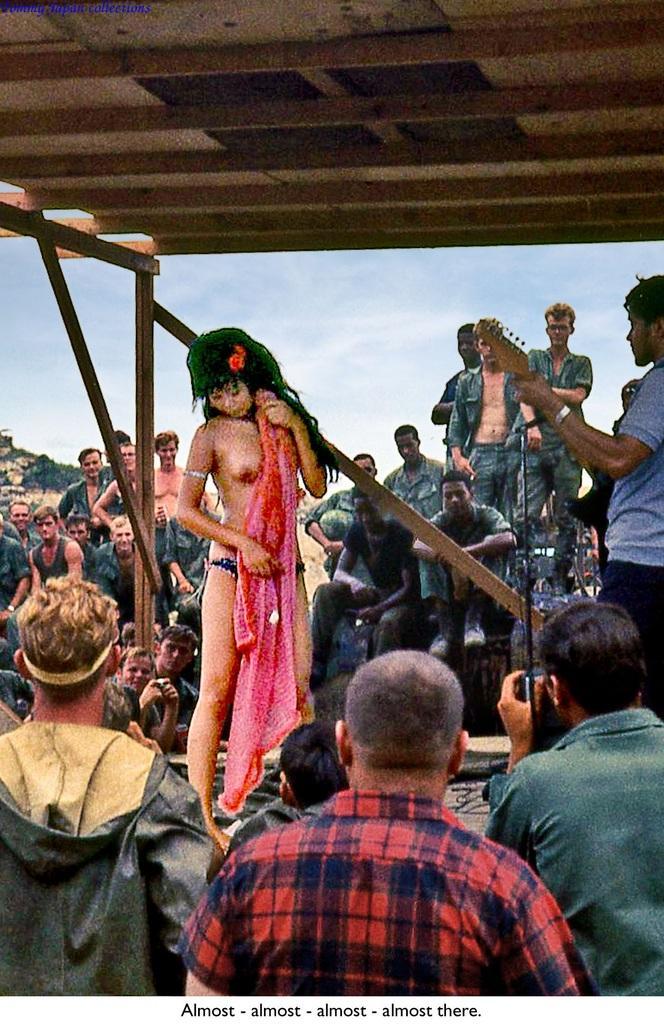Describe this image in one or two sentences. In this image, we can see a poster with some images and text. 